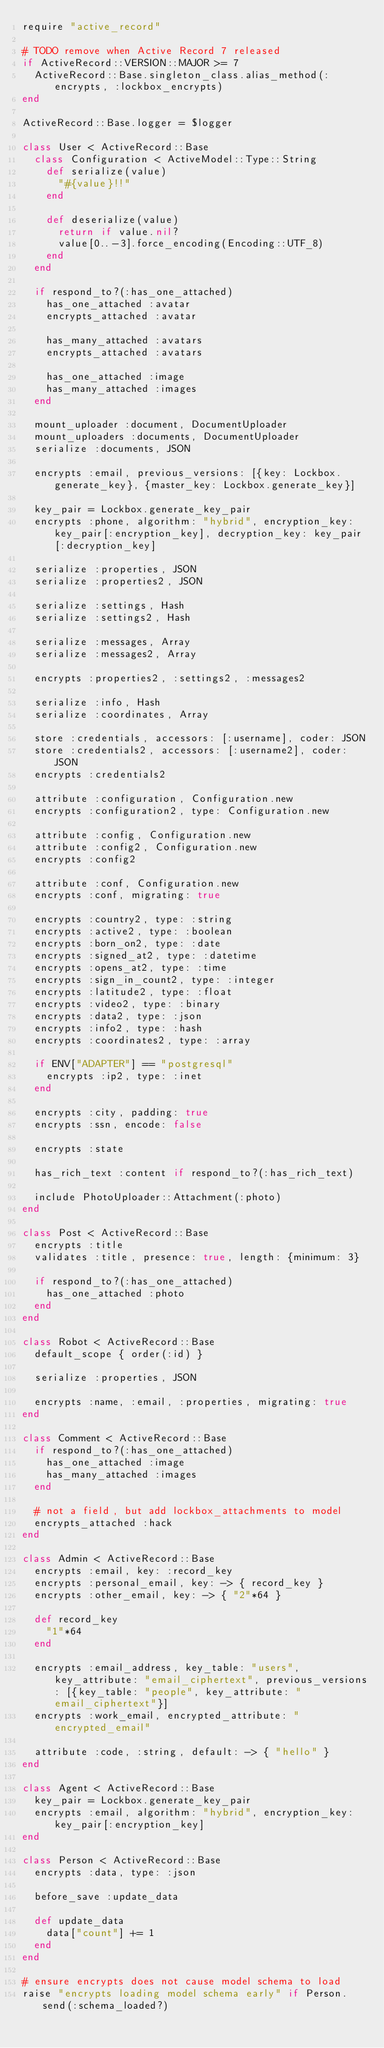Convert code to text. <code><loc_0><loc_0><loc_500><loc_500><_Ruby_>require "active_record"

# TODO remove when Active Record 7 released
if ActiveRecord::VERSION::MAJOR >= 7
  ActiveRecord::Base.singleton_class.alias_method(:encrypts, :lockbox_encrypts)
end

ActiveRecord::Base.logger = $logger

class User < ActiveRecord::Base
  class Configuration < ActiveModel::Type::String
    def serialize(value)
      "#{value}!!"
    end

    def deserialize(value)
      return if value.nil?
      value[0..-3].force_encoding(Encoding::UTF_8)
    end
  end

  if respond_to?(:has_one_attached)
    has_one_attached :avatar
    encrypts_attached :avatar

    has_many_attached :avatars
    encrypts_attached :avatars

    has_one_attached :image
    has_many_attached :images
  end

  mount_uploader :document, DocumentUploader
  mount_uploaders :documents, DocumentUploader
  serialize :documents, JSON

  encrypts :email, previous_versions: [{key: Lockbox.generate_key}, {master_key: Lockbox.generate_key}]

  key_pair = Lockbox.generate_key_pair
  encrypts :phone, algorithm: "hybrid", encryption_key: key_pair[:encryption_key], decryption_key: key_pair[:decryption_key]

  serialize :properties, JSON
  serialize :properties2, JSON

  serialize :settings, Hash
  serialize :settings2, Hash

  serialize :messages, Array
  serialize :messages2, Array

  encrypts :properties2, :settings2, :messages2

  serialize :info, Hash
  serialize :coordinates, Array

  store :credentials, accessors: [:username], coder: JSON
  store :credentials2, accessors: [:username2], coder: JSON
  encrypts :credentials2

  attribute :configuration, Configuration.new
  encrypts :configuration2, type: Configuration.new

  attribute :config, Configuration.new
  attribute :config2, Configuration.new
  encrypts :config2

  attribute :conf, Configuration.new
  encrypts :conf, migrating: true

  encrypts :country2, type: :string
  encrypts :active2, type: :boolean
  encrypts :born_on2, type: :date
  encrypts :signed_at2, type: :datetime
  encrypts :opens_at2, type: :time
  encrypts :sign_in_count2, type: :integer
  encrypts :latitude2, type: :float
  encrypts :video2, type: :binary
  encrypts :data2, type: :json
  encrypts :info2, type: :hash
  encrypts :coordinates2, type: :array

  if ENV["ADAPTER"] == "postgresql"
    encrypts :ip2, type: :inet
  end

  encrypts :city, padding: true
  encrypts :ssn, encode: false

  encrypts :state

  has_rich_text :content if respond_to?(:has_rich_text)

  include PhotoUploader::Attachment(:photo)
end

class Post < ActiveRecord::Base
  encrypts :title
  validates :title, presence: true, length: {minimum: 3}

  if respond_to?(:has_one_attached)
    has_one_attached :photo
  end
end

class Robot < ActiveRecord::Base
  default_scope { order(:id) }

  serialize :properties, JSON

  encrypts :name, :email, :properties, migrating: true
end

class Comment < ActiveRecord::Base
  if respond_to?(:has_one_attached)
    has_one_attached :image
    has_many_attached :images
  end

  # not a field, but add lockbox_attachments to model
  encrypts_attached :hack
end

class Admin < ActiveRecord::Base
  encrypts :email, key: :record_key
  encrypts :personal_email, key: -> { record_key }
  encrypts :other_email, key: -> { "2"*64 }

  def record_key
    "1"*64
  end

  encrypts :email_address, key_table: "users", key_attribute: "email_ciphertext", previous_versions: [{key_table: "people", key_attribute: "email_ciphertext"}]
  encrypts :work_email, encrypted_attribute: "encrypted_email"

  attribute :code, :string, default: -> { "hello" }
end

class Agent < ActiveRecord::Base
  key_pair = Lockbox.generate_key_pair
  encrypts :email, algorithm: "hybrid", encryption_key: key_pair[:encryption_key]
end

class Person < ActiveRecord::Base
  encrypts :data, type: :json

  before_save :update_data

  def update_data
    data["count"] += 1
  end
end

# ensure encrypts does not cause model schema to load
raise "encrypts loading model schema early" if Person.send(:schema_loaded?)
</code> 